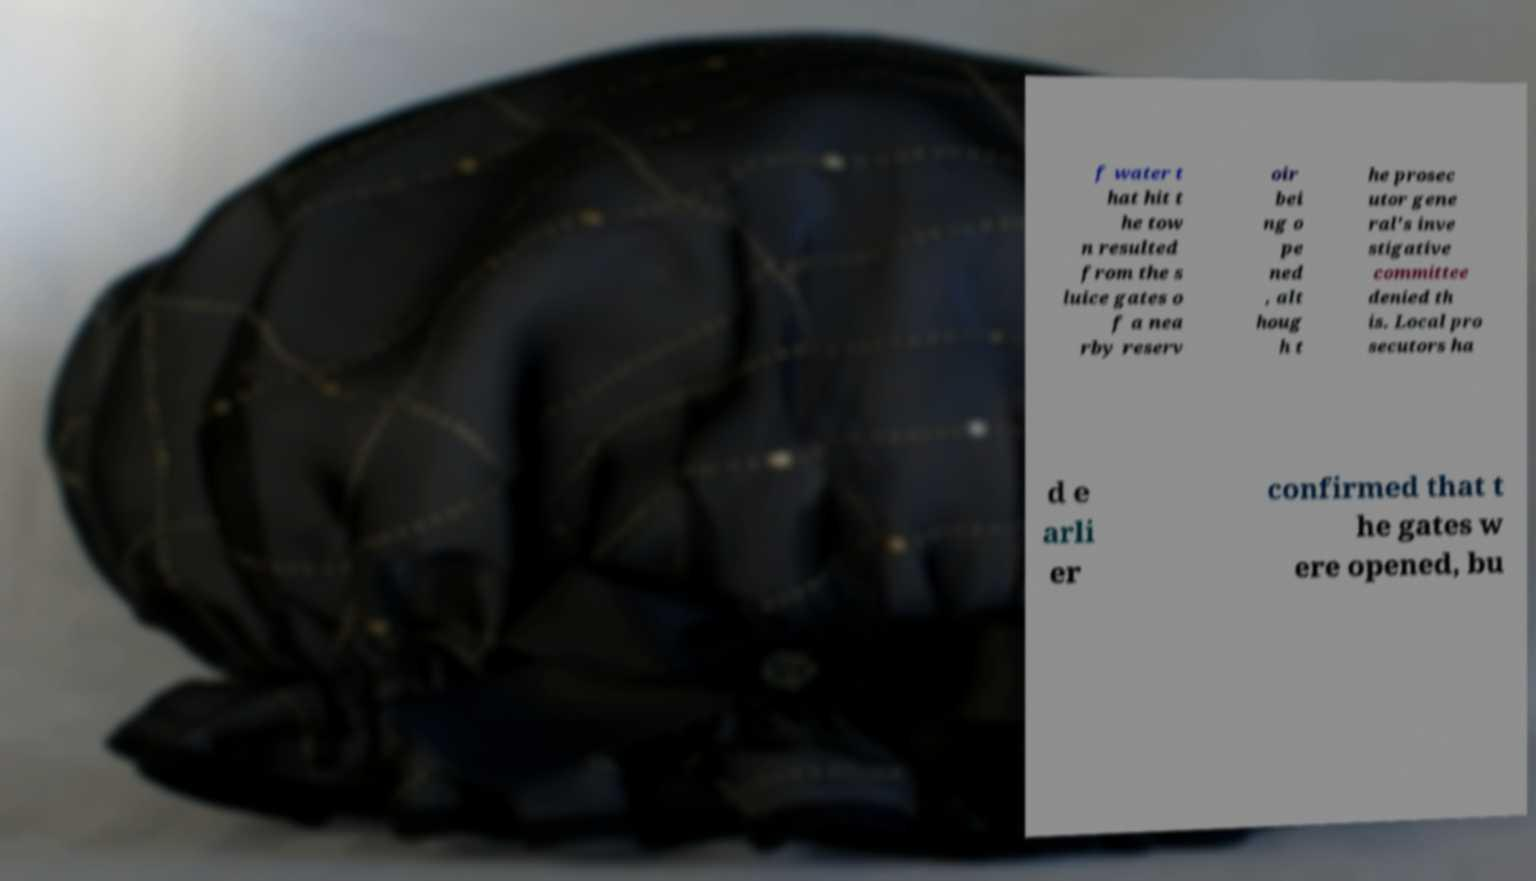I need the written content from this picture converted into text. Can you do that? f water t hat hit t he tow n resulted from the s luice gates o f a nea rby reserv oir bei ng o pe ned , alt houg h t he prosec utor gene ral's inve stigative committee denied th is. Local pro secutors ha d e arli er confirmed that t he gates w ere opened, bu 